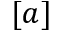Convert formula to latex. <formula><loc_0><loc_0><loc_500><loc_500>[ a ]</formula> 